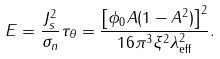<formula> <loc_0><loc_0><loc_500><loc_500>E = \frac { J _ { s } ^ { 2 } } { \sigma _ { n } } \tau _ { \theta } = \frac { \left [ \phi _ { 0 } A ( 1 - A ^ { 2 } ) \right ] ^ { 2 } } { 1 6 \pi ^ { 3 } \xi ^ { 2 } \lambda _ { \text {eff} } ^ { 2 } } .</formula> 